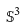Convert formula to latex. <formula><loc_0><loc_0><loc_500><loc_500>\mathbb { S } ^ { 3 }</formula> 